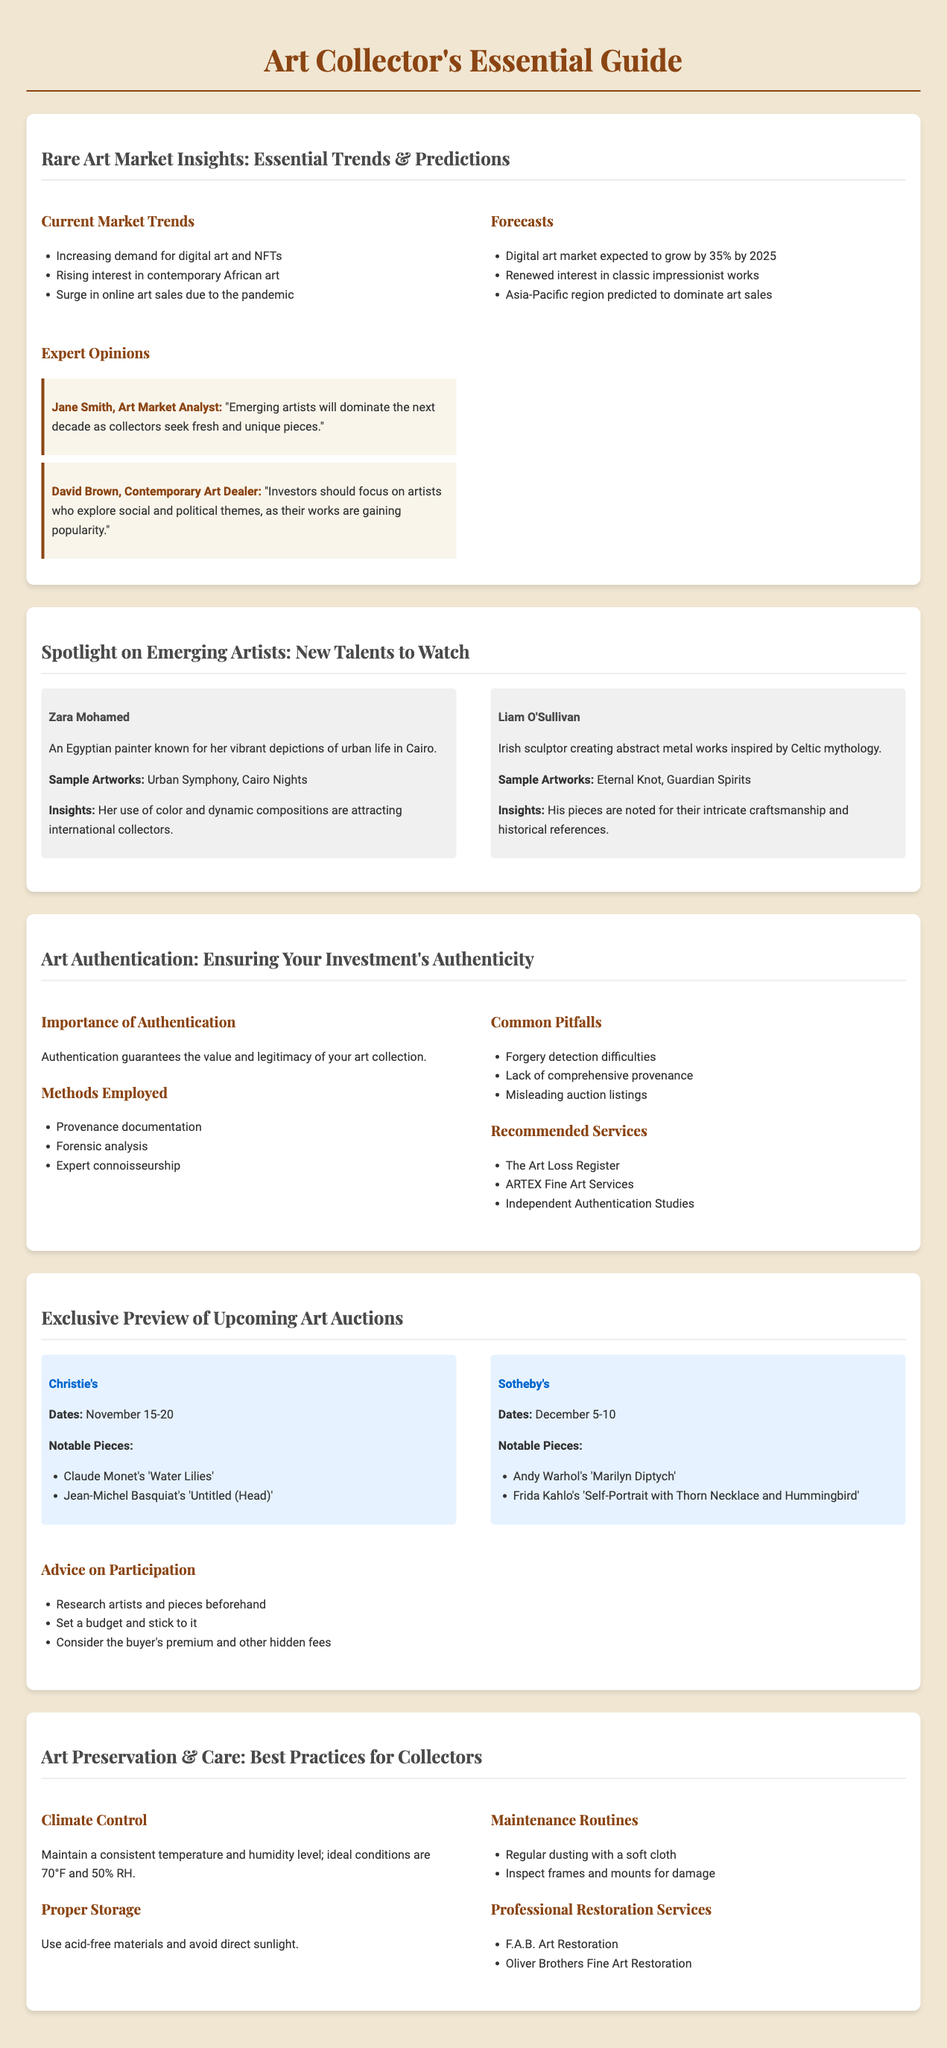What are the notable pieces at Christie's auction? The notable pieces at Christie's auction include Claude Monet's 'Water Lilies' and Jean-Michel Basquiat's 'Untitled (Head)'.
Answer: Claude Monet's 'Water Lilies', Jean-Michel Basquiat's 'Untitled (Head)' What is the predicted growth percentage of the digital art market by 2025? The predicted growth percentage of the digital art market is mentioned in the forecasts section of the document.
Answer: 35% Who is the artist known for vibrant depictions of urban life in Cairo? The document specifies that Zara Mohamed is the artist recognized for her vibrant depictions of urban life.
Answer: Zara Mohamed What important factors should be maintained for climate control of art? The document describes ideal conditions for climate control as a consistent temperature and humidity level.
Answer: 70°F and 50% RH Which auction house has sales scheduled for December 5-10? The auction house scheduling sales for December 5-10 is specified in the auction preview section.
Answer: Sotheby's What is a common pitfall in art authentication? The document lists several pitfalls, one of which is difficulties in detecting forgeries.
Answer: Forgery detection difficulties What method is used in art authentication? The document includes methods used in art authentication, specifically highlighting provenance documentation.
Answer: Provenance documentation What kind of artworks does Liam O'Sullivan create? The document mentions Liam O'Sullivan as an artist creating abstract metal works inspired by Celtic mythology.
Answer: Abstract metal works inspired by Celtic mythology 